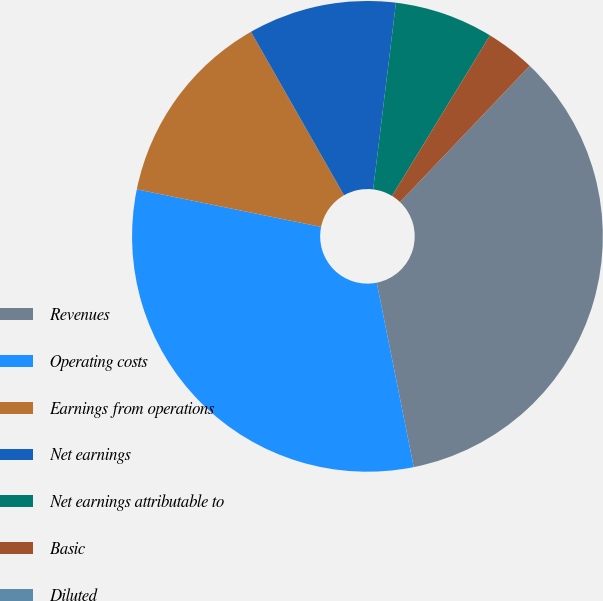Convert chart. <chart><loc_0><loc_0><loc_500><loc_500><pie_chart><fcel>Revenues<fcel>Operating costs<fcel>Earnings from operations<fcel>Net earnings<fcel>Net earnings attributable to<fcel>Basic<fcel>Diluted<nl><fcel>34.74%<fcel>31.35%<fcel>13.56%<fcel>10.17%<fcel>6.78%<fcel>3.39%<fcel>0.0%<nl></chart> 